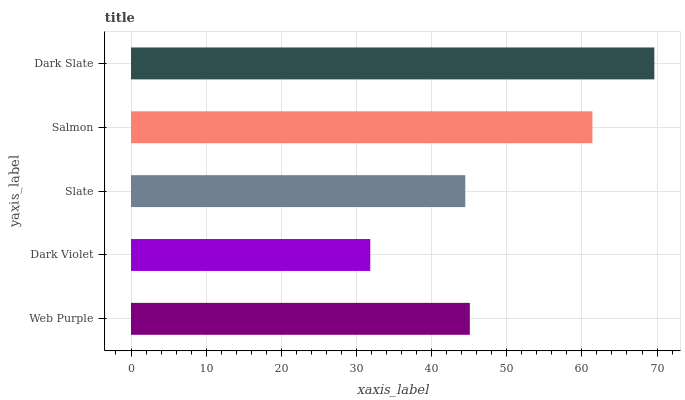Is Dark Violet the minimum?
Answer yes or no. Yes. Is Dark Slate the maximum?
Answer yes or no. Yes. Is Slate the minimum?
Answer yes or no. No. Is Slate the maximum?
Answer yes or no. No. Is Slate greater than Dark Violet?
Answer yes or no. Yes. Is Dark Violet less than Slate?
Answer yes or no. Yes. Is Dark Violet greater than Slate?
Answer yes or no. No. Is Slate less than Dark Violet?
Answer yes or no. No. Is Web Purple the high median?
Answer yes or no. Yes. Is Web Purple the low median?
Answer yes or no. Yes. Is Salmon the high median?
Answer yes or no. No. Is Dark Violet the low median?
Answer yes or no. No. 